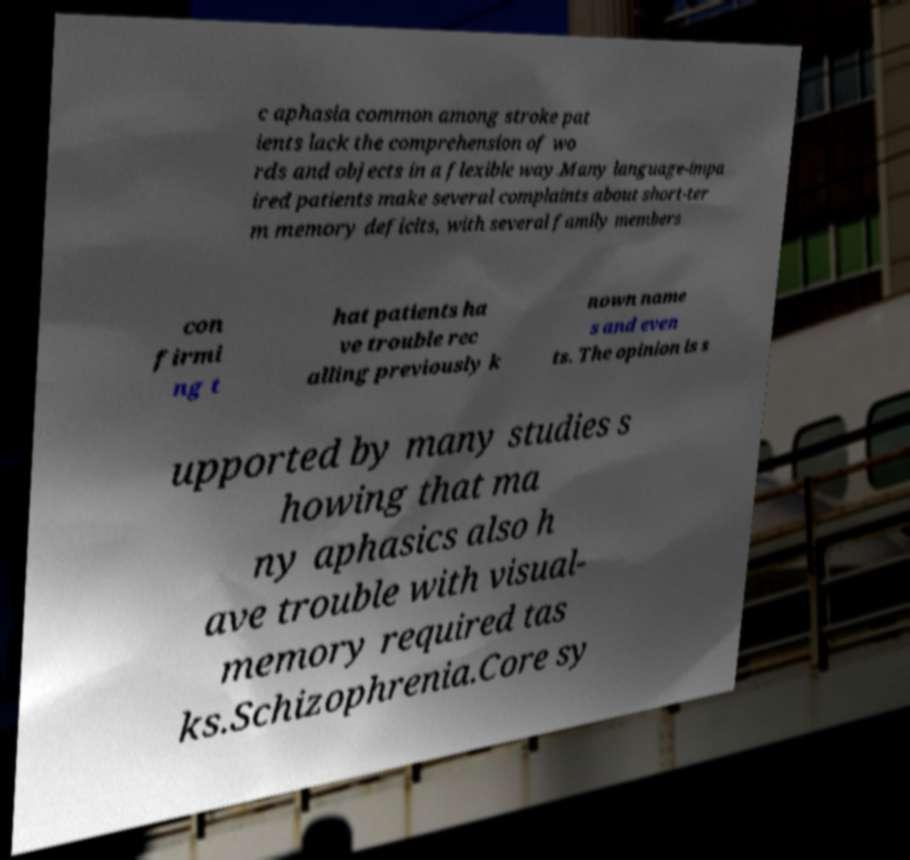Could you assist in decoding the text presented in this image and type it out clearly? c aphasia common among stroke pat ients lack the comprehension of wo rds and objects in a flexible way.Many language-impa ired patients make several complaints about short-ter m memory deficits, with several family members con firmi ng t hat patients ha ve trouble rec alling previously k nown name s and even ts. The opinion is s upported by many studies s howing that ma ny aphasics also h ave trouble with visual- memory required tas ks.Schizophrenia.Core sy 